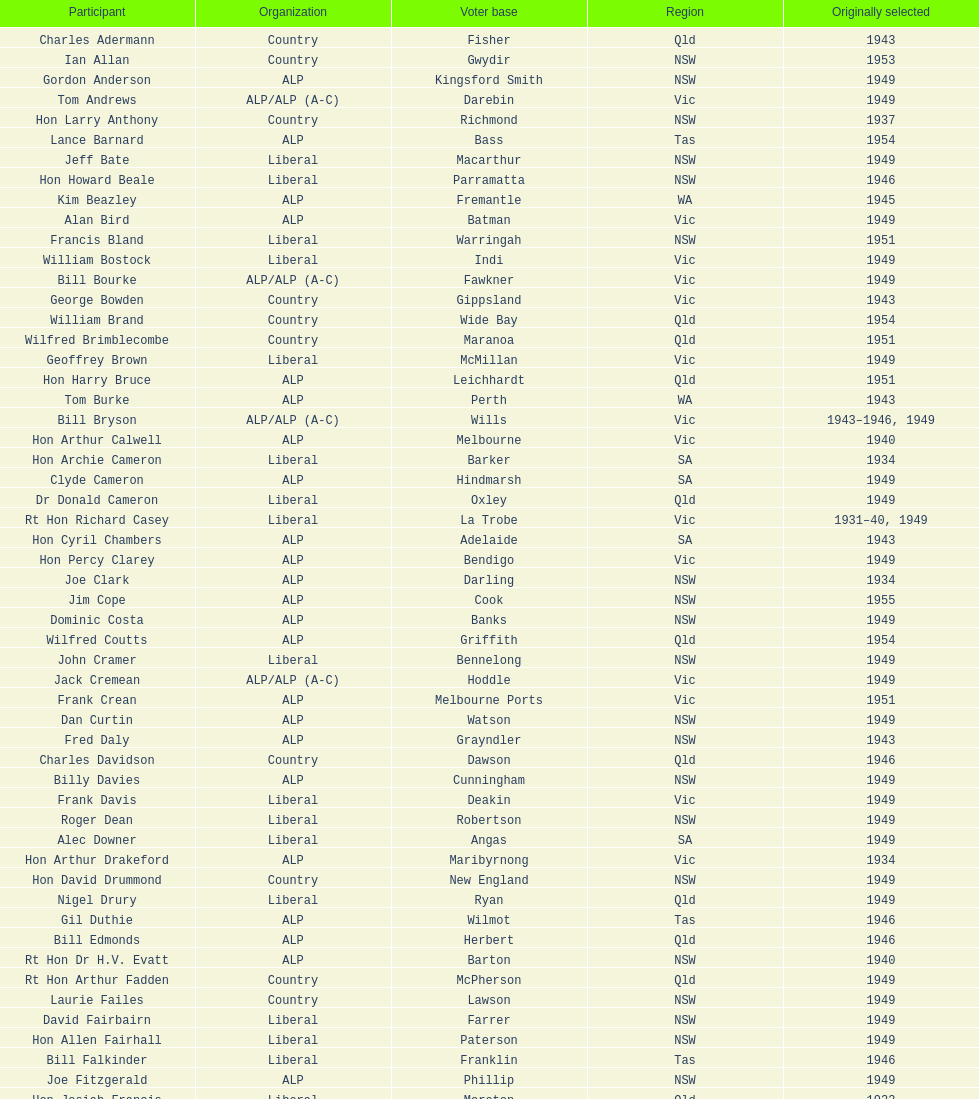Which party was elected the least? Country. 